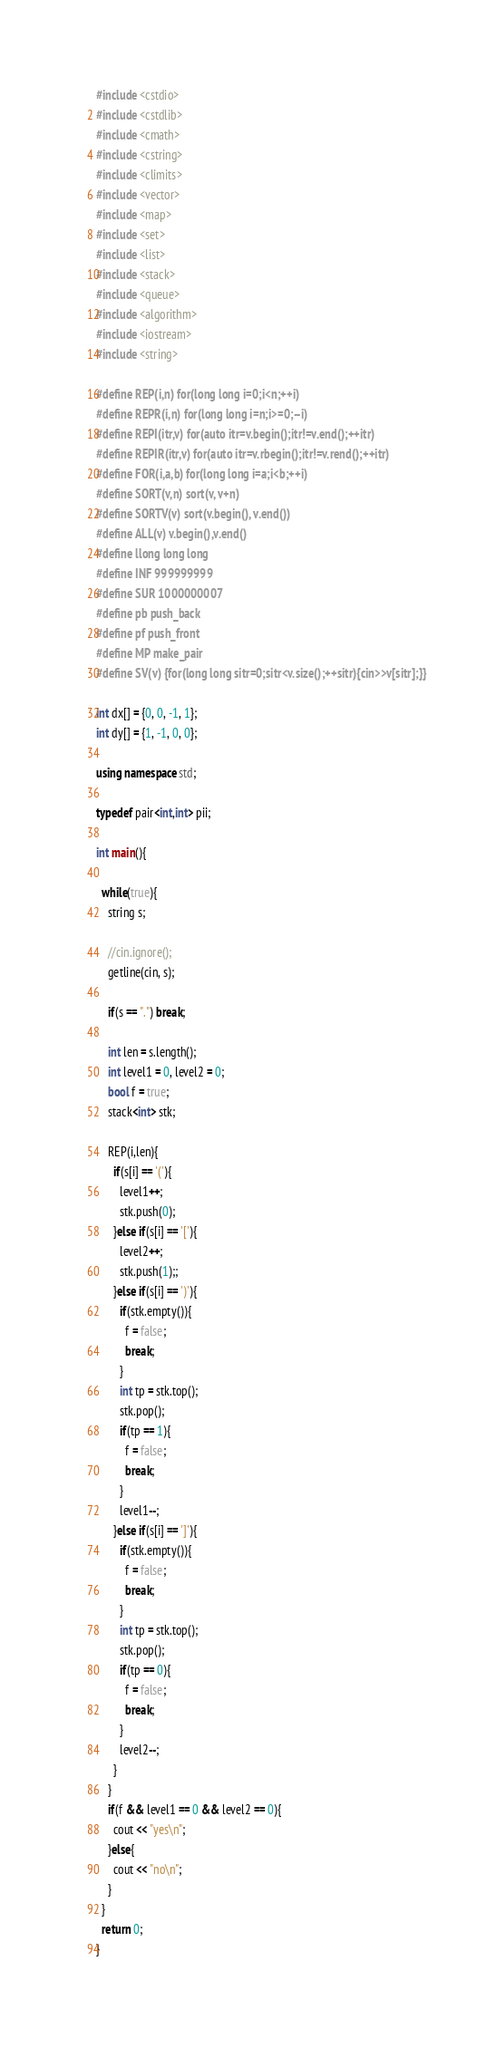<code> <loc_0><loc_0><loc_500><loc_500><_C++_>#include <cstdio>
#include <cstdlib>
#include <cmath>
#include <cstring>
#include <climits>
#include <vector>
#include <map>
#include <set>
#include <list>
#include <stack>
#include <queue>
#include <algorithm>
#include <iostream>
#include <string>

#define REP(i,n) for(long long i=0;i<n;++i)
#define REPR(i,n) for(long long i=n;i>=0;--i)
#define REPI(itr,v) for(auto itr=v.begin();itr!=v.end();++itr)
#define REPIR(itr,v) for(auto itr=v.rbegin();itr!=v.rend();++itr)
#define FOR(i,a,b) for(long long i=a;i<b;++i)
#define SORT(v,n) sort(v, v+n)
#define SORTV(v) sort(v.begin(), v.end())
#define ALL(v) v.begin(),v.end()
#define llong long long
#define INF 999999999
#define SUR 1000000007
#define pb push_back
#define pf push_front
#define MP make_pair
#define SV(v) {for(long long sitr=0;sitr<v.size();++sitr){cin>>v[sitr];}}

int dx[] = {0, 0, -1, 1};
int dy[] = {1, -1, 0, 0};

using namespace std;

typedef pair<int,int> pii;

int main(){

  while(true){
    string s;

    //cin.ignore();
    getline(cin, s);

    if(s == ".") break;

    int len = s.length();
    int level1 = 0, level2 = 0;
    bool f = true;
    stack<int> stk;

    REP(i,len){
      if(s[i] == '('){
        level1++;
        stk.push(0);
      }else if(s[i] == '['){
        level2++;
        stk.push(1);;
      }else if(s[i] == ')'){
        if(stk.empty()){
          f = false;
          break;
        }
        int tp = stk.top();
        stk.pop();
        if(tp == 1){
          f = false;
          break;
        }
        level1--;
      }else if(s[i] == ']'){
        if(stk.empty()){
          f = false;
          break;
        }
        int tp = stk.top();
        stk.pop();
        if(tp == 0){
          f = false;
          break;
        }
        level2--;
      }
    }
    if(f && level1 == 0 && level2 == 0){
      cout << "yes\n";
    }else{
      cout << "no\n";
    }
  }
  return 0;
}


</code> 